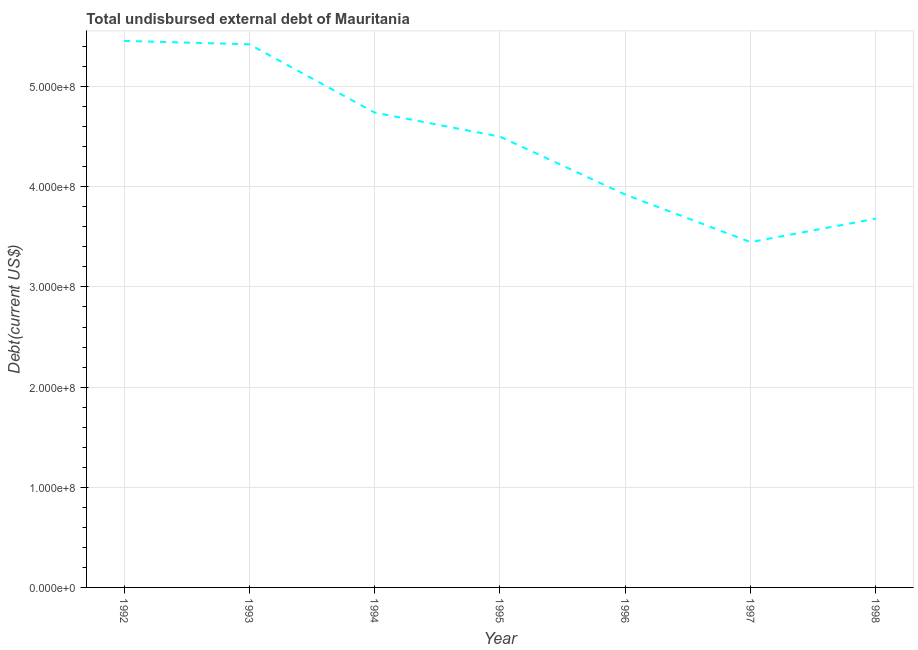What is the total debt in 1992?
Provide a short and direct response. 5.46e+08. Across all years, what is the maximum total debt?
Your answer should be very brief. 5.46e+08. Across all years, what is the minimum total debt?
Your answer should be compact. 3.45e+08. In which year was the total debt maximum?
Your answer should be compact. 1992. What is the sum of the total debt?
Keep it short and to the point. 3.12e+09. What is the difference between the total debt in 1996 and 1998?
Provide a succinct answer. 2.40e+07. What is the average total debt per year?
Give a very brief answer. 4.45e+08. What is the median total debt?
Your response must be concise. 4.50e+08. In how many years, is the total debt greater than 60000000 US$?
Offer a terse response. 7. What is the ratio of the total debt in 1992 to that in 1998?
Provide a short and direct response. 1.48. What is the difference between the highest and the second highest total debt?
Your response must be concise. 3.41e+06. Is the sum of the total debt in 1994 and 1995 greater than the maximum total debt across all years?
Provide a succinct answer. Yes. What is the difference between the highest and the lowest total debt?
Your answer should be compact. 2.01e+08. How many lines are there?
Keep it short and to the point. 1. What is the difference between two consecutive major ticks on the Y-axis?
Your response must be concise. 1.00e+08. Are the values on the major ticks of Y-axis written in scientific E-notation?
Offer a terse response. Yes. What is the title of the graph?
Offer a terse response. Total undisbursed external debt of Mauritania. What is the label or title of the X-axis?
Your response must be concise. Year. What is the label or title of the Y-axis?
Your response must be concise. Debt(current US$). What is the Debt(current US$) in 1992?
Make the answer very short. 5.46e+08. What is the Debt(current US$) in 1993?
Your answer should be compact. 5.42e+08. What is the Debt(current US$) of 1994?
Make the answer very short. 4.74e+08. What is the Debt(current US$) in 1995?
Keep it short and to the point. 4.50e+08. What is the Debt(current US$) in 1996?
Provide a succinct answer. 3.92e+08. What is the Debt(current US$) in 1997?
Ensure brevity in your answer.  3.45e+08. What is the Debt(current US$) in 1998?
Make the answer very short. 3.68e+08. What is the difference between the Debt(current US$) in 1992 and 1993?
Your answer should be compact. 3.41e+06. What is the difference between the Debt(current US$) in 1992 and 1994?
Ensure brevity in your answer.  7.16e+07. What is the difference between the Debt(current US$) in 1992 and 1995?
Give a very brief answer. 9.56e+07. What is the difference between the Debt(current US$) in 1992 and 1996?
Keep it short and to the point. 1.53e+08. What is the difference between the Debt(current US$) in 1992 and 1997?
Provide a succinct answer. 2.01e+08. What is the difference between the Debt(current US$) in 1992 and 1998?
Provide a short and direct response. 1.77e+08. What is the difference between the Debt(current US$) in 1993 and 1994?
Ensure brevity in your answer.  6.82e+07. What is the difference between the Debt(current US$) in 1993 and 1995?
Keep it short and to the point. 9.22e+07. What is the difference between the Debt(current US$) in 1993 and 1996?
Your response must be concise. 1.50e+08. What is the difference between the Debt(current US$) in 1993 and 1997?
Keep it short and to the point. 1.98e+08. What is the difference between the Debt(current US$) in 1993 and 1998?
Make the answer very short. 1.74e+08. What is the difference between the Debt(current US$) in 1994 and 1995?
Offer a terse response. 2.40e+07. What is the difference between the Debt(current US$) in 1994 and 1996?
Your response must be concise. 8.19e+07. What is the difference between the Debt(current US$) in 1994 and 1997?
Give a very brief answer. 1.29e+08. What is the difference between the Debt(current US$) in 1994 and 1998?
Your answer should be very brief. 1.06e+08. What is the difference between the Debt(current US$) in 1995 and 1996?
Your response must be concise. 5.79e+07. What is the difference between the Debt(current US$) in 1995 and 1997?
Offer a very short reply. 1.05e+08. What is the difference between the Debt(current US$) in 1995 and 1998?
Your response must be concise. 8.19e+07. What is the difference between the Debt(current US$) in 1996 and 1997?
Offer a terse response. 4.75e+07. What is the difference between the Debt(current US$) in 1996 and 1998?
Ensure brevity in your answer.  2.40e+07. What is the difference between the Debt(current US$) in 1997 and 1998?
Make the answer very short. -2.35e+07. What is the ratio of the Debt(current US$) in 1992 to that in 1994?
Ensure brevity in your answer.  1.15. What is the ratio of the Debt(current US$) in 1992 to that in 1995?
Your answer should be compact. 1.21. What is the ratio of the Debt(current US$) in 1992 to that in 1996?
Provide a succinct answer. 1.39. What is the ratio of the Debt(current US$) in 1992 to that in 1997?
Give a very brief answer. 1.58. What is the ratio of the Debt(current US$) in 1992 to that in 1998?
Make the answer very short. 1.48. What is the ratio of the Debt(current US$) in 1993 to that in 1994?
Your answer should be very brief. 1.14. What is the ratio of the Debt(current US$) in 1993 to that in 1995?
Offer a very short reply. 1.21. What is the ratio of the Debt(current US$) in 1993 to that in 1996?
Offer a terse response. 1.38. What is the ratio of the Debt(current US$) in 1993 to that in 1997?
Your answer should be compact. 1.57. What is the ratio of the Debt(current US$) in 1993 to that in 1998?
Offer a terse response. 1.47. What is the ratio of the Debt(current US$) in 1994 to that in 1995?
Provide a succinct answer. 1.05. What is the ratio of the Debt(current US$) in 1994 to that in 1996?
Ensure brevity in your answer.  1.21. What is the ratio of the Debt(current US$) in 1994 to that in 1997?
Offer a very short reply. 1.38. What is the ratio of the Debt(current US$) in 1994 to that in 1998?
Your response must be concise. 1.29. What is the ratio of the Debt(current US$) in 1995 to that in 1996?
Your answer should be compact. 1.15. What is the ratio of the Debt(current US$) in 1995 to that in 1997?
Your response must be concise. 1.3. What is the ratio of the Debt(current US$) in 1995 to that in 1998?
Provide a short and direct response. 1.22. What is the ratio of the Debt(current US$) in 1996 to that in 1997?
Offer a terse response. 1.14. What is the ratio of the Debt(current US$) in 1996 to that in 1998?
Offer a very short reply. 1.06. What is the ratio of the Debt(current US$) in 1997 to that in 1998?
Provide a short and direct response. 0.94. 